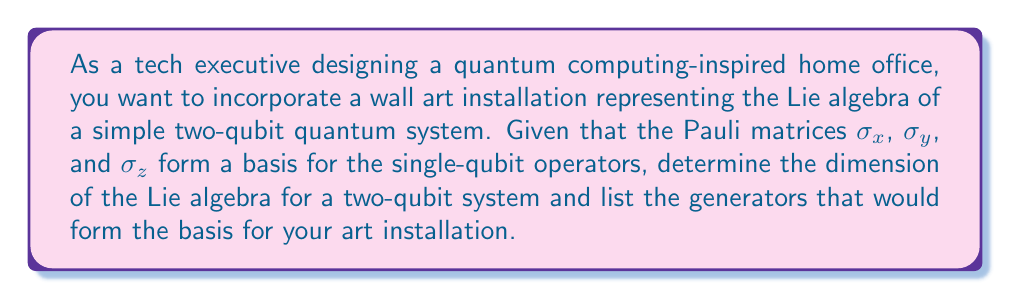What is the answer to this math problem? To solve this problem, let's follow these steps:

1) First, recall that the Pauli matrices and the identity matrix form a basis for all 2x2 complex matrices:

   $\sigma_0 = I = \begin{pmatrix} 1 & 0 \\ 0 & 1 \end{pmatrix}$
   $\sigma_x = \begin{pmatrix} 0 & 1 \\ 1 & 0 \end{pmatrix}$
   $\sigma_y = \begin{pmatrix} 0 & -i \\ i & 0 \end{pmatrix}$
   $\sigma_z = \begin{pmatrix} 1 & 0 \\ 0 & -1 \end{pmatrix}$

2) For a two-qubit system, we need to consider tensor products of these matrices. The general form of operators on two qubits will be:

   $A \otimes B$, where $A$ and $B$ are each one of $\{\sigma_0, \sigma_x, \sigma_y, \sigma_z\}$

3) This gives us 16 possible combinations: $4 \times 4 = 16$

4) However, the Lie algebra consists of traceless Hermitian matrices. The identity matrix $\sigma_0 \otimes \sigma_0$ has a non-zero trace and thus is not part of the Lie algebra.

5) Therefore, the dimension of the Lie algebra is 15.

6) The generators of this Lie algebra can be listed as:

   $\sigma_x \otimes I, \sigma_y \otimes I, \sigma_z \otimes I$
   $I \otimes \sigma_x, I \otimes \sigma_y, I \otimes \sigma_z$
   $\sigma_x \otimes \sigma_x, \sigma_x \otimes \sigma_y, \sigma_x \otimes \sigma_z$
   $\sigma_y \otimes \sigma_x, \sigma_y \otimes \sigma_y, \sigma_y \otimes \sigma_z$
   $\sigma_z \otimes \sigma_x, \sigma_z \otimes \sigma_y, \sigma_z \otimes \sigma_z$

These 15 generators form a basis for the Lie algebra of the two-qubit system and would be the elements to represent in the art installation.
Answer: The dimension of the Lie algebra for a two-qubit system is 15, and the generators are:

$\{\sigma_x \otimes I, \sigma_y \otimes I, \sigma_z \otimes I, I \otimes \sigma_x, I \otimes \sigma_y, I \otimes \sigma_z, \sigma_x \otimes \sigma_x, \sigma_x \otimes \sigma_y, \sigma_x \otimes \sigma_z, \sigma_y \otimes \sigma_x, \sigma_y \otimes \sigma_y, \sigma_y \otimes \sigma_z, \sigma_z \otimes \sigma_x, \sigma_z \otimes \sigma_y, \sigma_z \otimes \sigma_z\}$ 